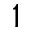Convert formula to latex. <formula><loc_0><loc_0><loc_500><loc_500>1</formula> 